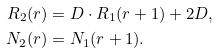Convert formula to latex. <formula><loc_0><loc_0><loc_500><loc_500>R _ { 2 } ( r ) & = D \cdot R _ { 1 } ( r + 1 ) + 2 D , \\ N _ { 2 } ( r ) & = N _ { 1 } ( r + 1 ) .</formula> 